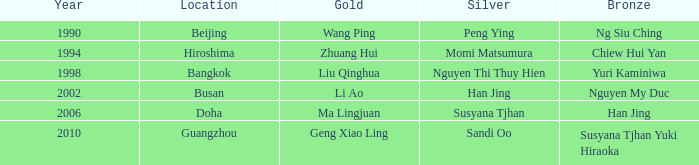What Gold has the Year of 1994? Zhuang Hui. 